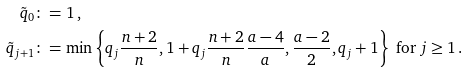<formula> <loc_0><loc_0><loc_500><loc_500>\tilde { q } _ { 0 } & \colon = 1 \, , \\ \tilde { q } _ { j + 1 } & \colon = \min \left \{ q _ { j } \frac { n + 2 } { n } , 1 + q _ { j } \frac { n + 2 } { n } \frac { a - 4 } { a } , \frac { a - 2 } { 2 } , q _ { j } + 1 \right \} \text { for } j \geq 1 \, .</formula> 